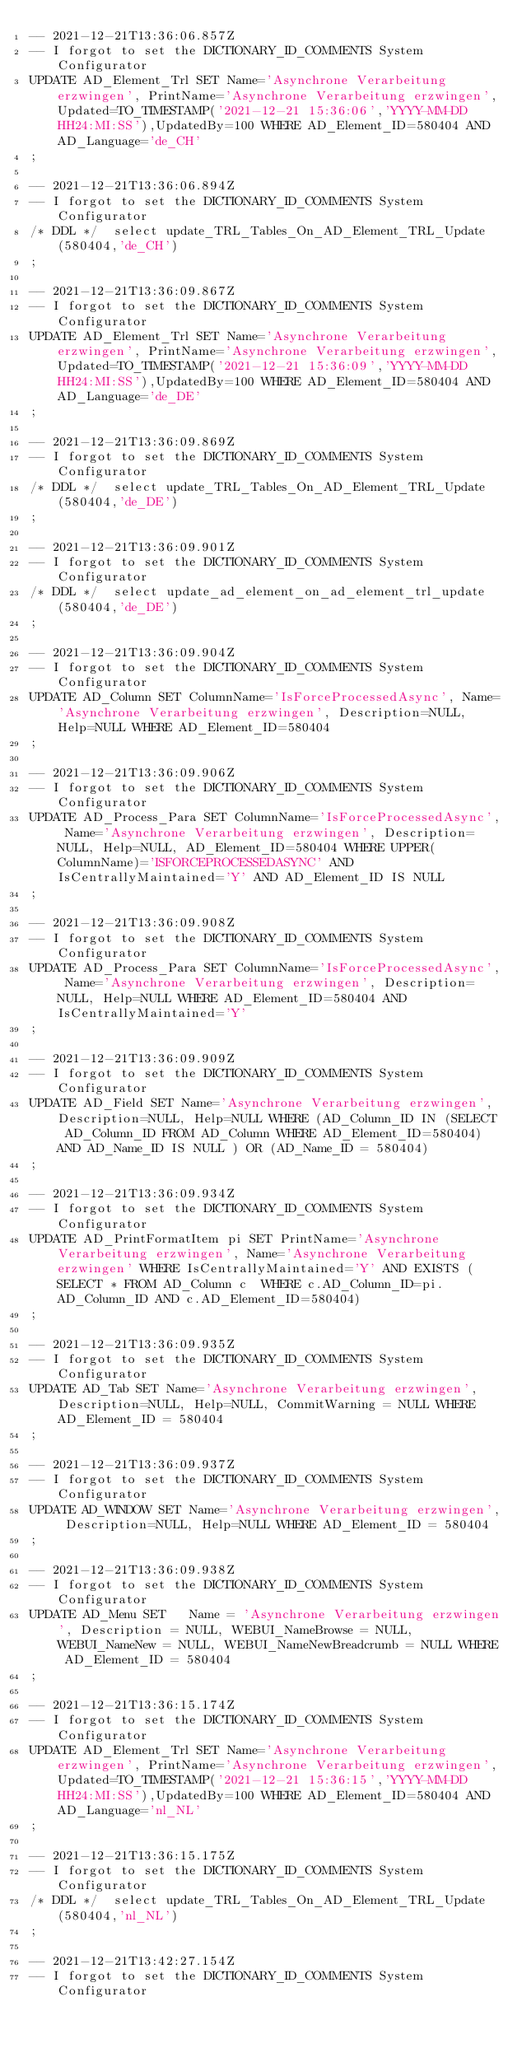Convert code to text. <code><loc_0><loc_0><loc_500><loc_500><_SQL_>-- 2021-12-21T13:36:06.857Z
-- I forgot to set the DICTIONARY_ID_COMMENTS System Configurator
UPDATE AD_Element_Trl SET Name='Asynchrone Verarbeitung erzwingen', PrintName='Asynchrone Verarbeitung erzwingen',Updated=TO_TIMESTAMP('2021-12-21 15:36:06','YYYY-MM-DD HH24:MI:SS'),UpdatedBy=100 WHERE AD_Element_ID=580404 AND AD_Language='de_CH'
;

-- 2021-12-21T13:36:06.894Z
-- I forgot to set the DICTIONARY_ID_COMMENTS System Configurator
/* DDL */  select update_TRL_Tables_On_AD_Element_TRL_Update(580404,'de_CH') 
;

-- 2021-12-21T13:36:09.867Z
-- I forgot to set the DICTIONARY_ID_COMMENTS System Configurator
UPDATE AD_Element_Trl SET Name='Asynchrone Verarbeitung erzwingen', PrintName='Asynchrone Verarbeitung erzwingen',Updated=TO_TIMESTAMP('2021-12-21 15:36:09','YYYY-MM-DD HH24:MI:SS'),UpdatedBy=100 WHERE AD_Element_ID=580404 AND AD_Language='de_DE'
;

-- 2021-12-21T13:36:09.869Z
-- I forgot to set the DICTIONARY_ID_COMMENTS System Configurator
/* DDL */  select update_TRL_Tables_On_AD_Element_TRL_Update(580404,'de_DE') 
;

-- 2021-12-21T13:36:09.901Z
-- I forgot to set the DICTIONARY_ID_COMMENTS System Configurator
/* DDL */  select update_ad_element_on_ad_element_trl_update(580404,'de_DE') 
;

-- 2021-12-21T13:36:09.904Z
-- I forgot to set the DICTIONARY_ID_COMMENTS System Configurator
UPDATE AD_Column SET ColumnName='IsForceProcessedAsync', Name='Asynchrone Verarbeitung erzwingen', Description=NULL, Help=NULL WHERE AD_Element_ID=580404
;

-- 2021-12-21T13:36:09.906Z
-- I forgot to set the DICTIONARY_ID_COMMENTS System Configurator
UPDATE AD_Process_Para SET ColumnName='IsForceProcessedAsync', Name='Asynchrone Verarbeitung erzwingen', Description=NULL, Help=NULL, AD_Element_ID=580404 WHERE UPPER(ColumnName)='ISFORCEPROCESSEDASYNC' AND IsCentrallyMaintained='Y' AND AD_Element_ID IS NULL
;

-- 2021-12-21T13:36:09.908Z
-- I forgot to set the DICTIONARY_ID_COMMENTS System Configurator
UPDATE AD_Process_Para SET ColumnName='IsForceProcessedAsync', Name='Asynchrone Verarbeitung erzwingen', Description=NULL, Help=NULL WHERE AD_Element_ID=580404 AND IsCentrallyMaintained='Y'
;

-- 2021-12-21T13:36:09.909Z
-- I forgot to set the DICTIONARY_ID_COMMENTS System Configurator
UPDATE AD_Field SET Name='Asynchrone Verarbeitung erzwingen', Description=NULL, Help=NULL WHERE (AD_Column_ID IN (SELECT AD_Column_ID FROM AD_Column WHERE AD_Element_ID=580404) AND AD_Name_ID IS NULL ) OR (AD_Name_ID = 580404)
;

-- 2021-12-21T13:36:09.934Z
-- I forgot to set the DICTIONARY_ID_COMMENTS System Configurator
UPDATE AD_PrintFormatItem pi SET PrintName='Asynchrone Verarbeitung erzwingen', Name='Asynchrone Verarbeitung erzwingen' WHERE IsCentrallyMaintained='Y' AND EXISTS (SELECT * FROM AD_Column c  WHERE c.AD_Column_ID=pi.AD_Column_ID AND c.AD_Element_ID=580404)
;

-- 2021-12-21T13:36:09.935Z
-- I forgot to set the DICTIONARY_ID_COMMENTS System Configurator
UPDATE AD_Tab SET Name='Asynchrone Verarbeitung erzwingen', Description=NULL, Help=NULL, CommitWarning = NULL WHERE AD_Element_ID = 580404
;

-- 2021-12-21T13:36:09.937Z
-- I forgot to set the DICTIONARY_ID_COMMENTS System Configurator
UPDATE AD_WINDOW SET Name='Asynchrone Verarbeitung erzwingen', Description=NULL, Help=NULL WHERE AD_Element_ID = 580404
;

-- 2021-12-21T13:36:09.938Z
-- I forgot to set the DICTIONARY_ID_COMMENTS System Configurator
UPDATE AD_Menu SET   Name = 'Asynchrone Verarbeitung erzwingen', Description = NULL, WEBUI_NameBrowse = NULL, WEBUI_NameNew = NULL, WEBUI_NameNewBreadcrumb = NULL WHERE AD_Element_ID = 580404
;

-- 2021-12-21T13:36:15.174Z
-- I forgot to set the DICTIONARY_ID_COMMENTS System Configurator
UPDATE AD_Element_Trl SET Name='Asynchrone Verarbeitung erzwingen', PrintName='Asynchrone Verarbeitung erzwingen',Updated=TO_TIMESTAMP('2021-12-21 15:36:15','YYYY-MM-DD HH24:MI:SS'),UpdatedBy=100 WHERE AD_Element_ID=580404 AND AD_Language='nl_NL'
;

-- 2021-12-21T13:36:15.175Z
-- I forgot to set the DICTIONARY_ID_COMMENTS System Configurator
/* DDL */  select update_TRL_Tables_On_AD_Element_TRL_Update(580404,'nl_NL') 
;

-- 2021-12-21T13:42:27.154Z
-- I forgot to set the DICTIONARY_ID_COMMENTS System Configurator</code> 